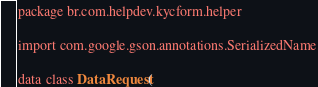<code> <loc_0><loc_0><loc_500><loc_500><_Kotlin_>package br.com.helpdev.kycform.helper

import com.google.gson.annotations.SerializedName

data class DataRequest(</code> 